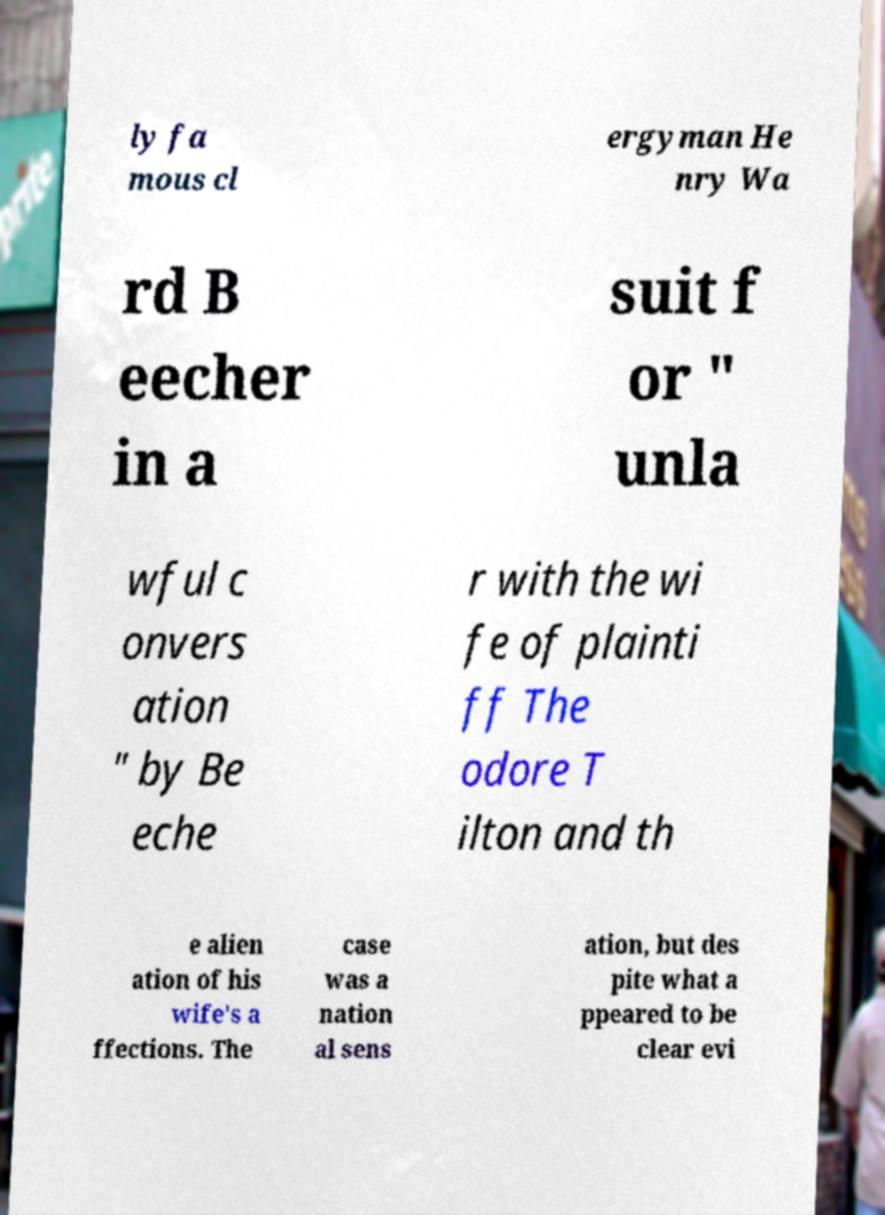Please read and relay the text visible in this image. What does it say? ly fa mous cl ergyman He nry Wa rd B eecher in a suit f or " unla wful c onvers ation " by Be eche r with the wi fe of plainti ff The odore T ilton and th e alien ation of his wife's a ffections. The case was a nation al sens ation, but des pite what a ppeared to be clear evi 